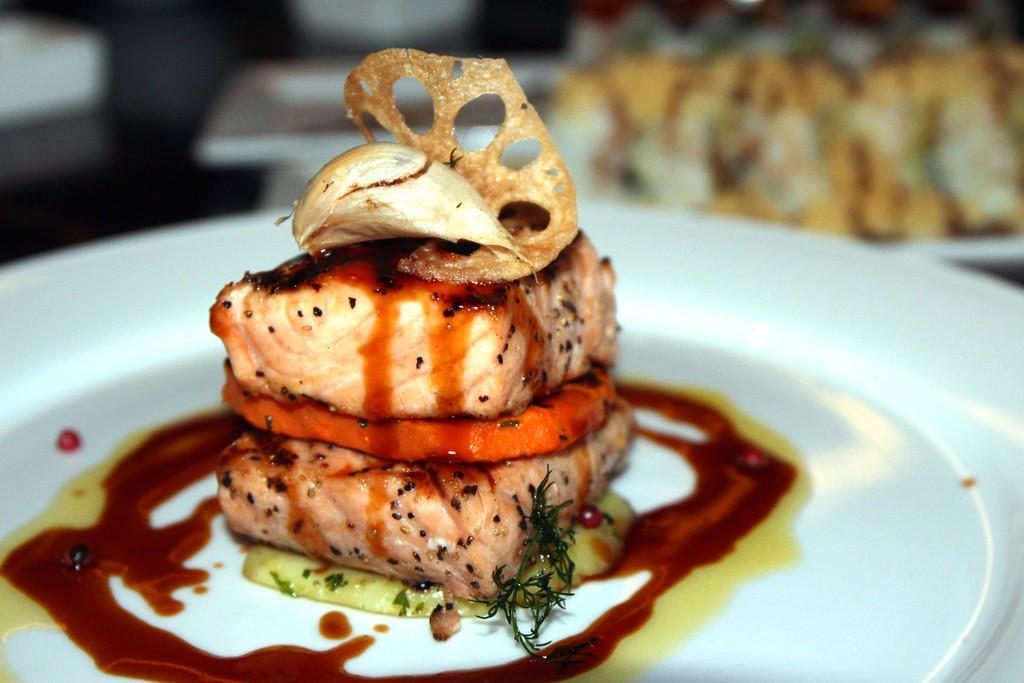Please provide a concise description of this image. In the image there is some cooked food item served with sauces on a white plate, the background of the plate is blur. 